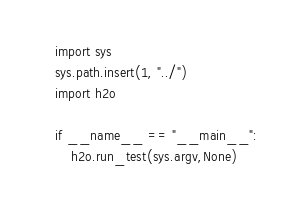<code> <loc_0><loc_0><loc_500><loc_500><_Python_>import sys
sys.path.insert(1, "../")
import h2o

if __name__ == "__main__":
    h2o.run_test(sys.argv,None)</code> 